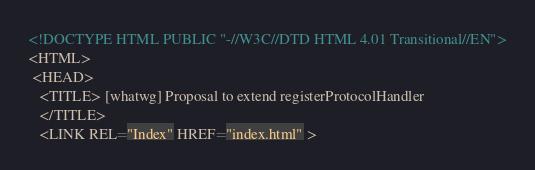<code> <loc_0><loc_0><loc_500><loc_500><_HTML_><!DOCTYPE HTML PUBLIC "-//W3C//DTD HTML 4.01 Transitional//EN">
<HTML>
 <HEAD>
   <TITLE> [whatwg] Proposal to extend registerProtocolHandler
   </TITLE>
   <LINK REL="Index" HREF="index.html" ></code> 